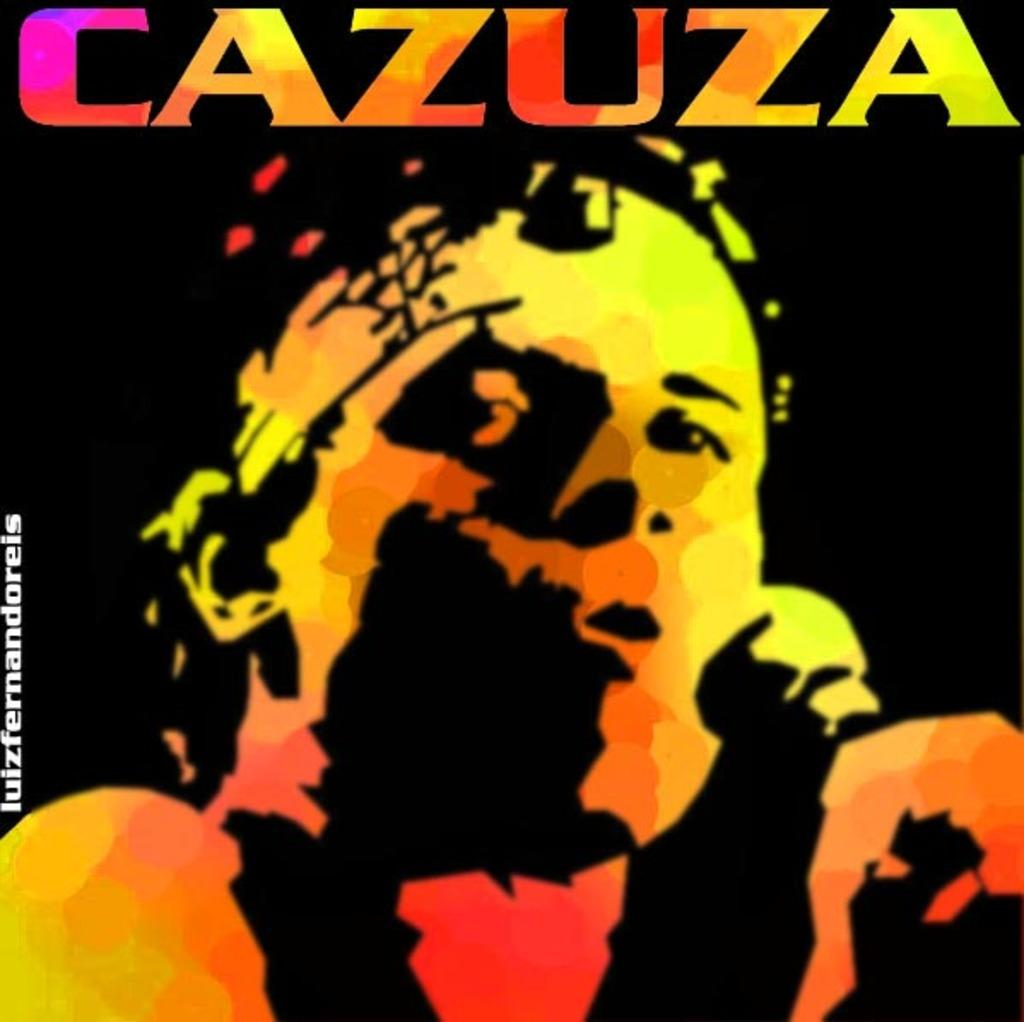<image>
Present a compact description of the photo's key features. Cazuza with a microphone on a picture or a album cover 